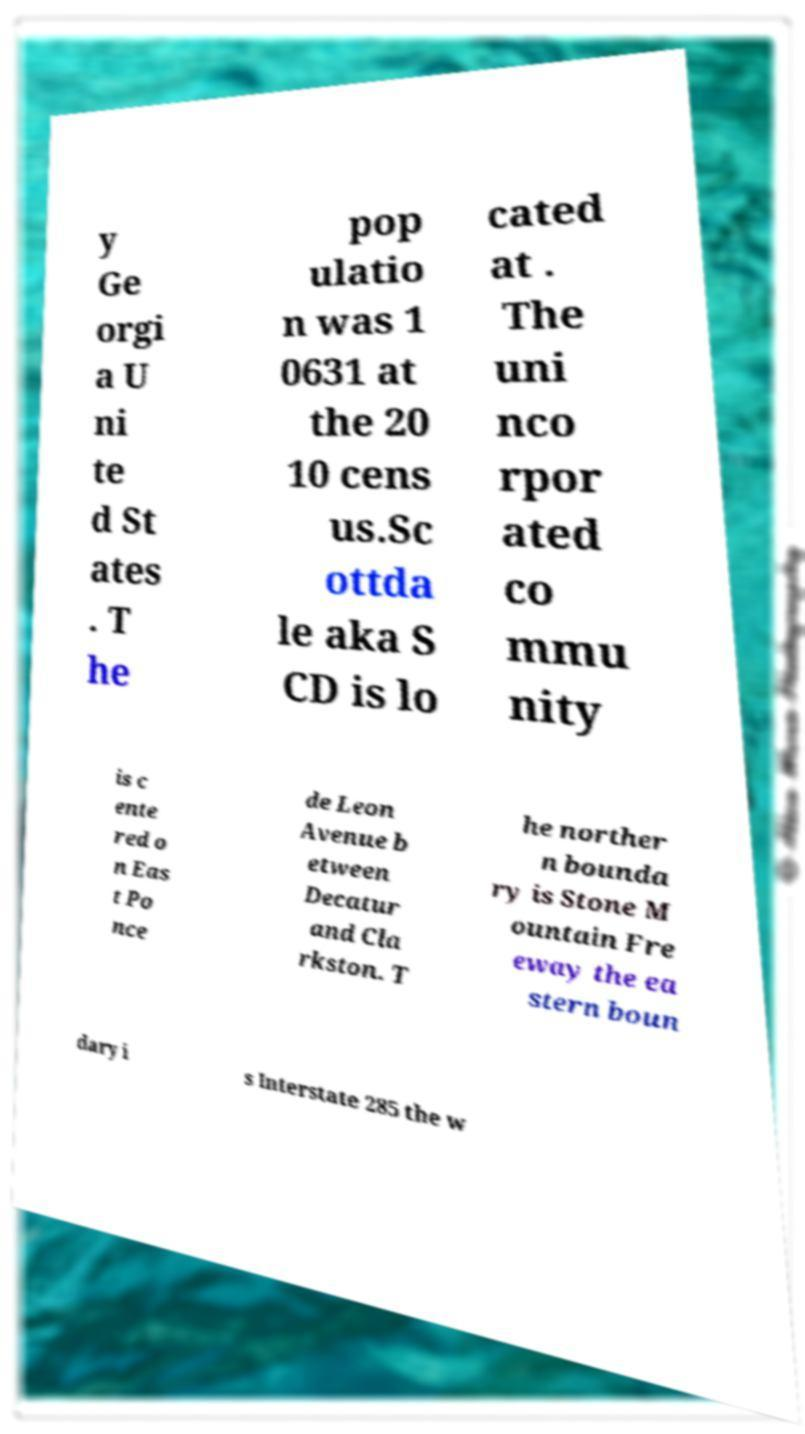I need the written content from this picture converted into text. Can you do that? y Ge orgi a U ni te d St ates . T he pop ulatio n was 1 0631 at the 20 10 cens us.Sc ottda le aka S CD is lo cated at . The uni nco rpor ated co mmu nity is c ente red o n Eas t Po nce de Leon Avenue b etween Decatur and Cla rkston. T he norther n bounda ry is Stone M ountain Fre eway the ea stern boun dary i s Interstate 285 the w 